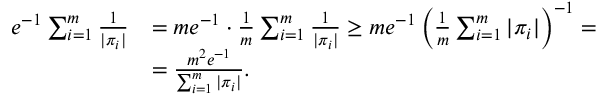<formula> <loc_0><loc_0><loc_500><loc_500>\begin{array} { r l } { e ^ { - 1 } \sum _ { i = 1 } ^ { m } \frac { 1 } { | \pi _ { i } | } } & { = m e ^ { - 1 } \cdot \frac { 1 } { m } \sum _ { i = 1 } ^ { m } \frac { 1 } { | \pi _ { i } | } \geq m e ^ { - 1 } \left ( \frac { 1 } { m } \sum _ { i = 1 } ^ { m } | \pi _ { i } | \right ) ^ { - 1 } = } \\ & { = \frac { m ^ { 2 } e ^ { - 1 } } { \sum _ { i = 1 } ^ { m } | \pi _ { i } | } . } \end{array}</formula> 